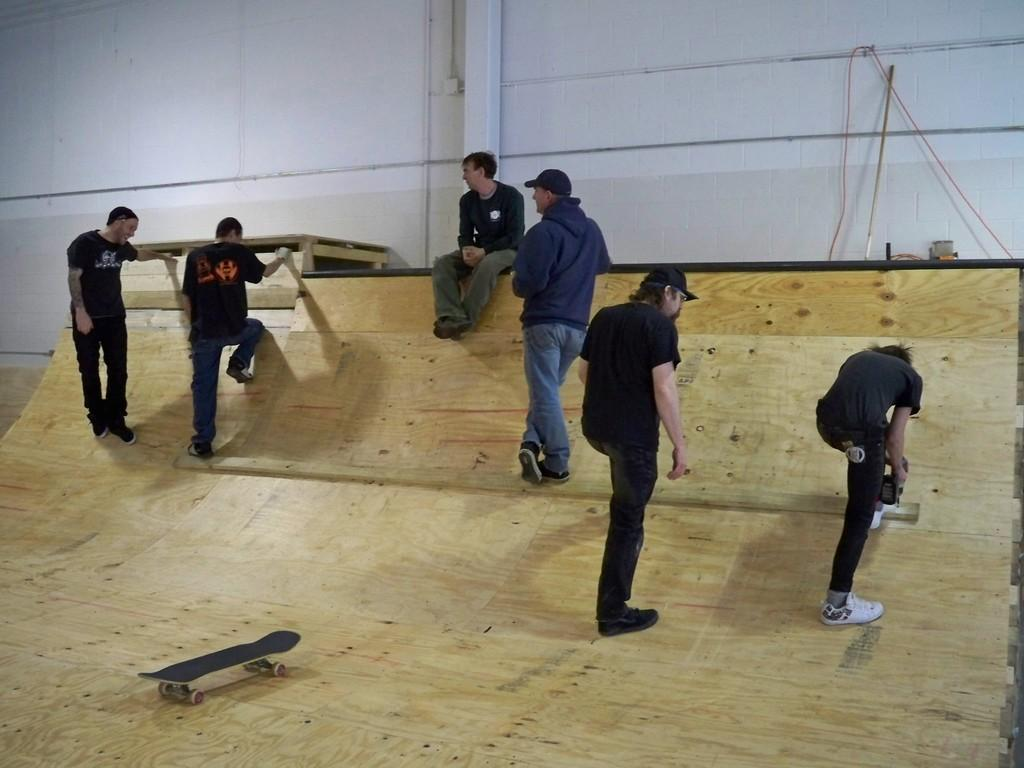What is the person in the image doing? There is a person sitting in the image, but their activity is not specified. How many people are standing in the image? There are five people standing in the image. What type of location is depicted in the image? The setting appears to be an indoor skatepark. What can be seen on the ground in the image? There is a skateboard visible in the image. What is present on the wall in the image? There is a wall in the image, but no specific details about the wall are provided. What object resembles a stick in the image? There is an object that looks like a stick in the image. What type of eggnog is being served in the image? There is no eggnog present in the image. How many dogs are visible in the image? There are no dogs visible in the image. 